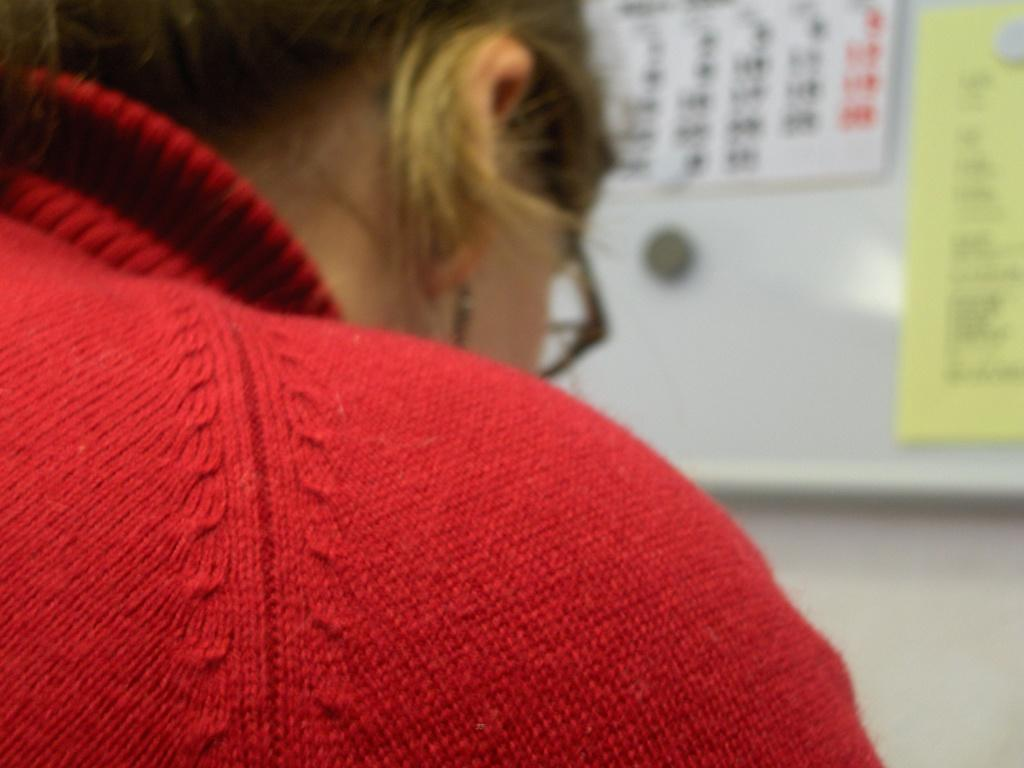Who is present in the image? There is a woman in the image. What is the woman wearing? The woman is wearing a red sweater. What accessory is the woman wearing? The woman is wearing spectacles. What can be seen in the background of the image? There is a wall in the background of the image. What items are on the wall? There is a calendar and a paper pasted on the wall. What type of curtain can be seen hanging from the ceiling in the image? There is no curtain present in the image. How much payment is the woman receiving in the image? There is no indication of payment or any financial transaction in the image. 